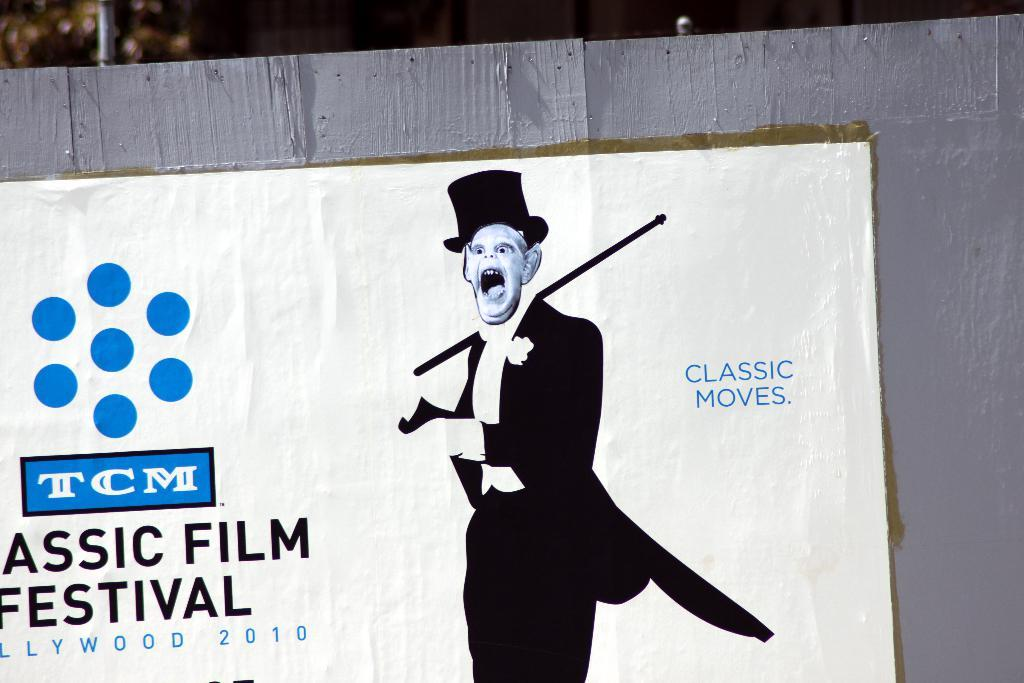What is the main object in the foreground of the image? There is a board in the foreground of the image. What is on the board? There is a poster on the board. What can be found on the poster? The poster contains text and images. How would you describe the background of the image? The background of the image is blurry. How many ladybugs can be seen crawling on the tin in the image? There is no tin or ladybugs present in the image. 